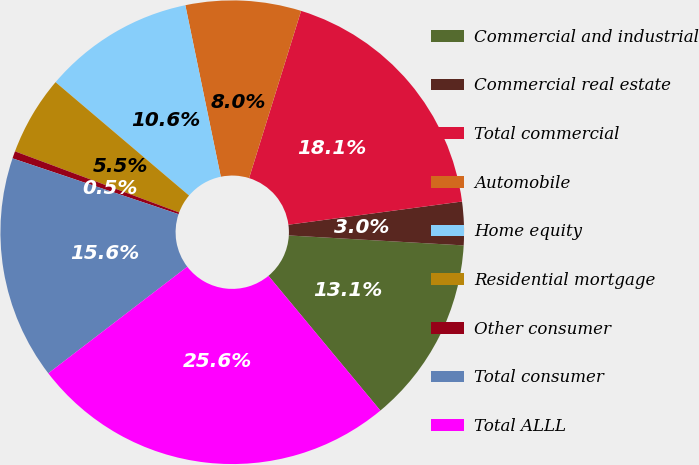Convert chart to OTSL. <chart><loc_0><loc_0><loc_500><loc_500><pie_chart><fcel>Commercial and industrial<fcel>Commercial real estate<fcel>Total commercial<fcel>Automobile<fcel>Home equity<fcel>Residential mortgage<fcel>Other consumer<fcel>Total consumer<fcel>Total ALLL<nl><fcel>13.06%<fcel>3.02%<fcel>18.08%<fcel>8.04%<fcel>10.55%<fcel>5.53%<fcel>0.51%<fcel>15.57%<fcel>25.61%<nl></chart> 